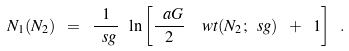<formula> <loc_0><loc_0><loc_500><loc_500>N _ { 1 } ( N _ { 2 } ) \ = \ \frac { 1 } { \ s g } \ \ln \left [ \frac { \ a G } { 2 } \ \ w t ( N _ { 2 } ; \ s g ) \ + \ 1 \right ] \ .</formula> 